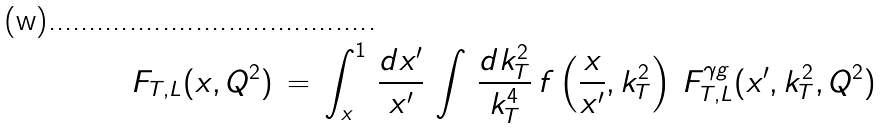<formula> <loc_0><loc_0><loc_500><loc_500>F _ { T , L } ( x , Q ^ { 2 } ) \, = \, \int _ { x } ^ { 1 } \, \frac { d x ^ { \prime } } { x ^ { \prime } } \, \int \, \frac { d k _ { T } ^ { 2 } } { k _ { T } ^ { 4 } } \, f \left ( \frac { x } { x ^ { \prime } } , k _ { T } ^ { 2 } \right ) \, F _ { T , L } ^ { \gamma g } ( x ^ { \prime } , k _ { T } ^ { 2 } , Q ^ { 2 } )</formula> 